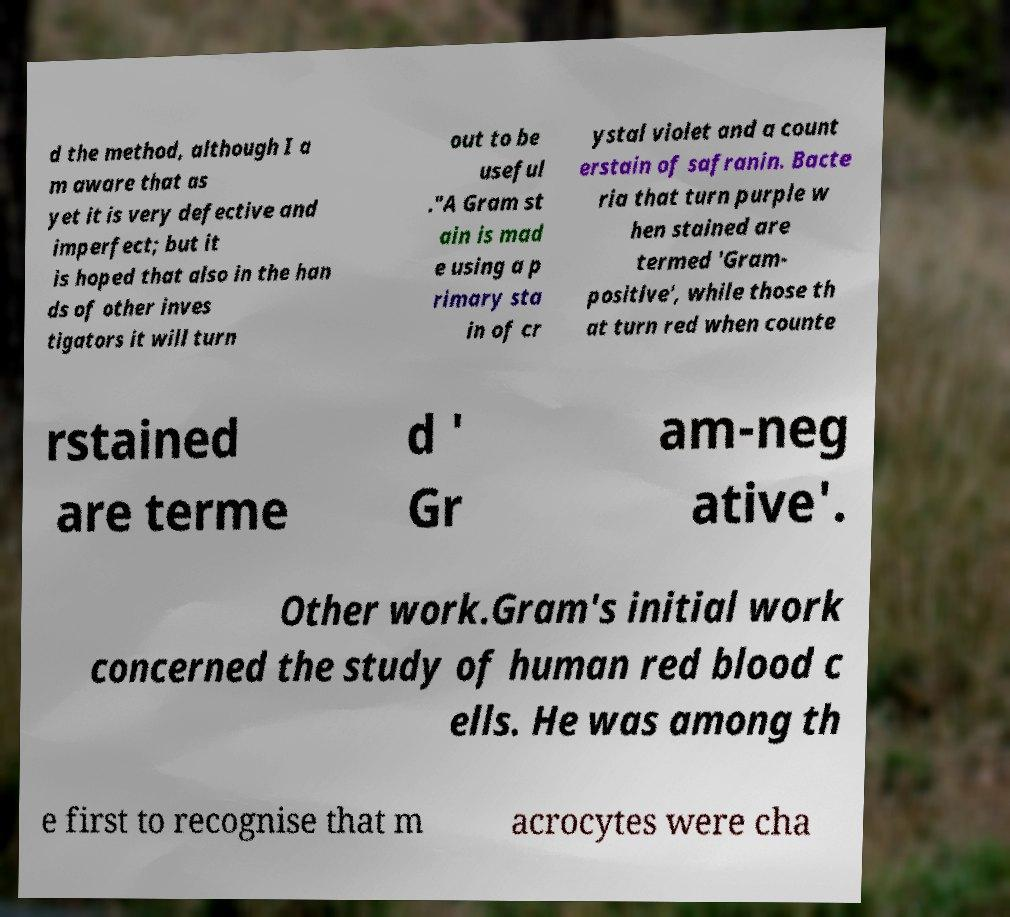What messages or text are displayed in this image? I need them in a readable, typed format. d the method, although I a m aware that as yet it is very defective and imperfect; but it is hoped that also in the han ds of other inves tigators it will turn out to be useful ."A Gram st ain is mad e using a p rimary sta in of cr ystal violet and a count erstain of safranin. Bacte ria that turn purple w hen stained are termed 'Gram- positive', while those th at turn red when counte rstained are terme d ' Gr am-neg ative'. Other work.Gram's initial work concerned the study of human red blood c ells. He was among th e first to recognise that m acrocytes were cha 